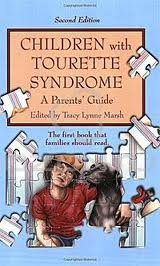What useful insights might a parent gain from this book? Parents can expect to gain practical advice on understanding and coping with Tourette Syndrome, including management techniques, emotional support strategies, and real-life case studies that provide a deeper insight into living with this condition. 